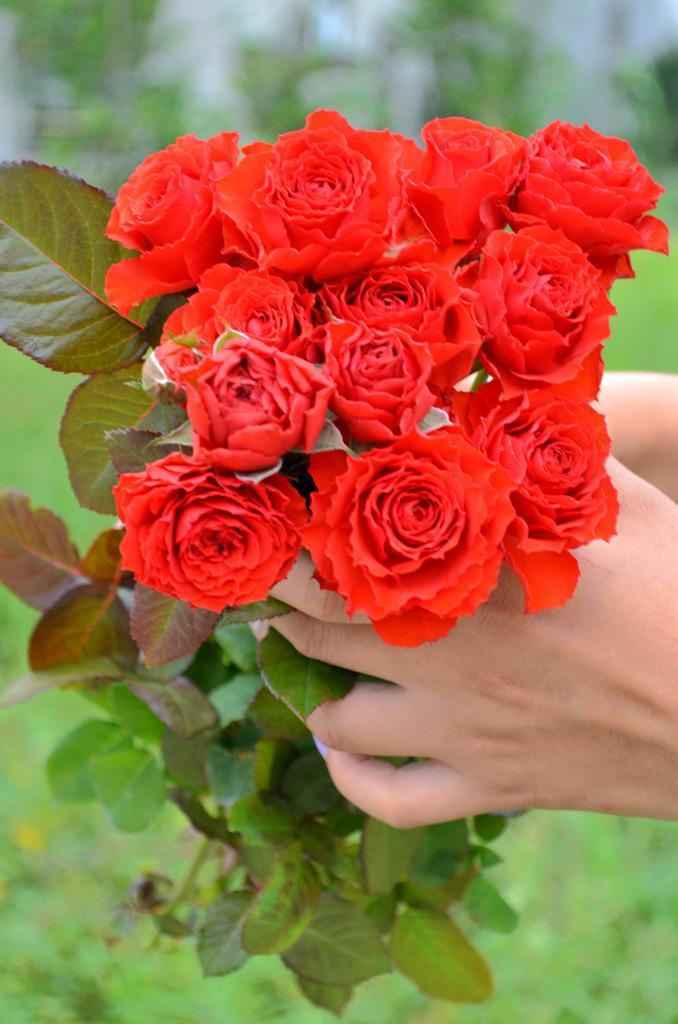Describe this image in one or two sentences. A person is holding flowers and leaves. Background it is blur. 